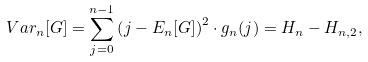Convert formula to latex. <formula><loc_0><loc_0><loc_500><loc_500>V a r _ { n } [ G ] = \sum _ { j = 0 } ^ { n - 1 } { \left ( j - E _ { n } [ G ] \right ) ^ { 2 } \cdot g _ { n } ( j ) } = H _ { n } - H _ { n , 2 } ,</formula> 